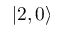<formula> <loc_0><loc_0><loc_500><loc_500>| 2 , 0 \rangle</formula> 